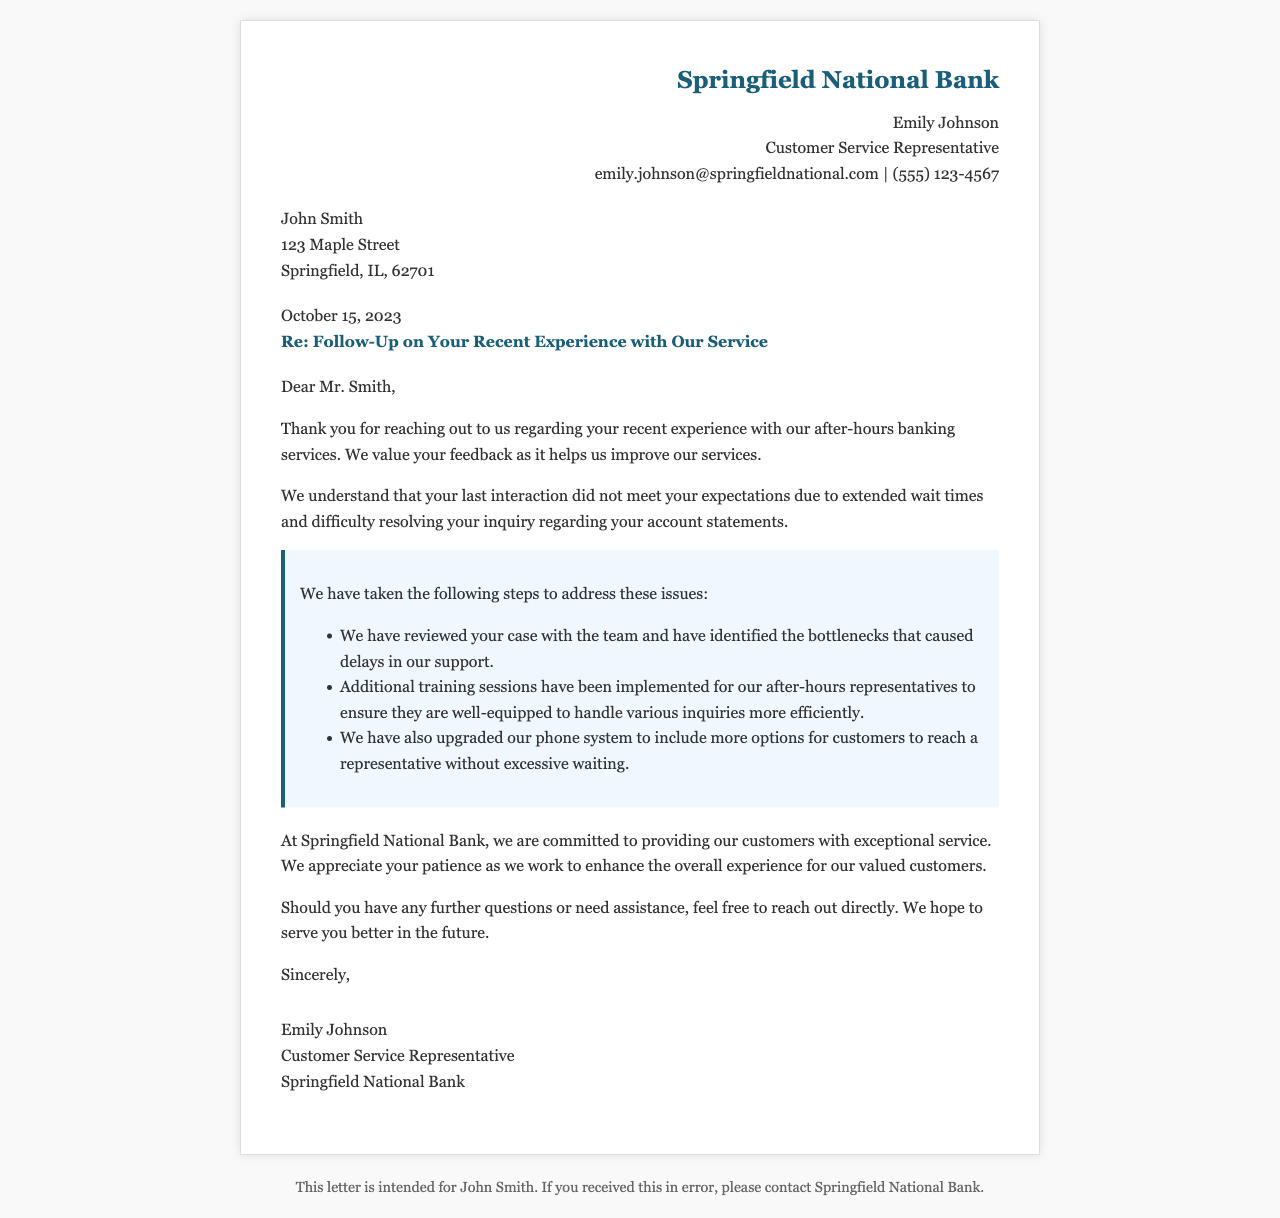What is the date of the letter? The date mentioned in the letter indicates when it was written, which is stated in a prominent position.
Answer: October 15, 2023 Who is the Customer Service Representative? The representative's name is given in the header of the letter, providing contact information as well.
Answer: Emily Johnson What issue did the customer experience? The letter explains a specific problem encountered by the customer in their recent interaction with the service.
Answer: Extended wait times What has been upgraded to improve service? The document lists improvements made, referring to a specific part of the infrastructure affecting customer interaction.
Answer: Phone system What is one of the steps taken to address customer concerns? One of the steps suggests a proactive measure taken to ensure better service based on the identified problems.
Answer: Additional training sessions Why is customer feedback important according to the letter? The letter emphasizes the role of feedback in enhancing services, highlighting its significance in the overall approach.
Answer: To improve our services What does the customer service representative invite the customer to do? The representative extends an offer for ongoing communication with the customer for any future issues or inquiries.
Answer: Reach out directly 